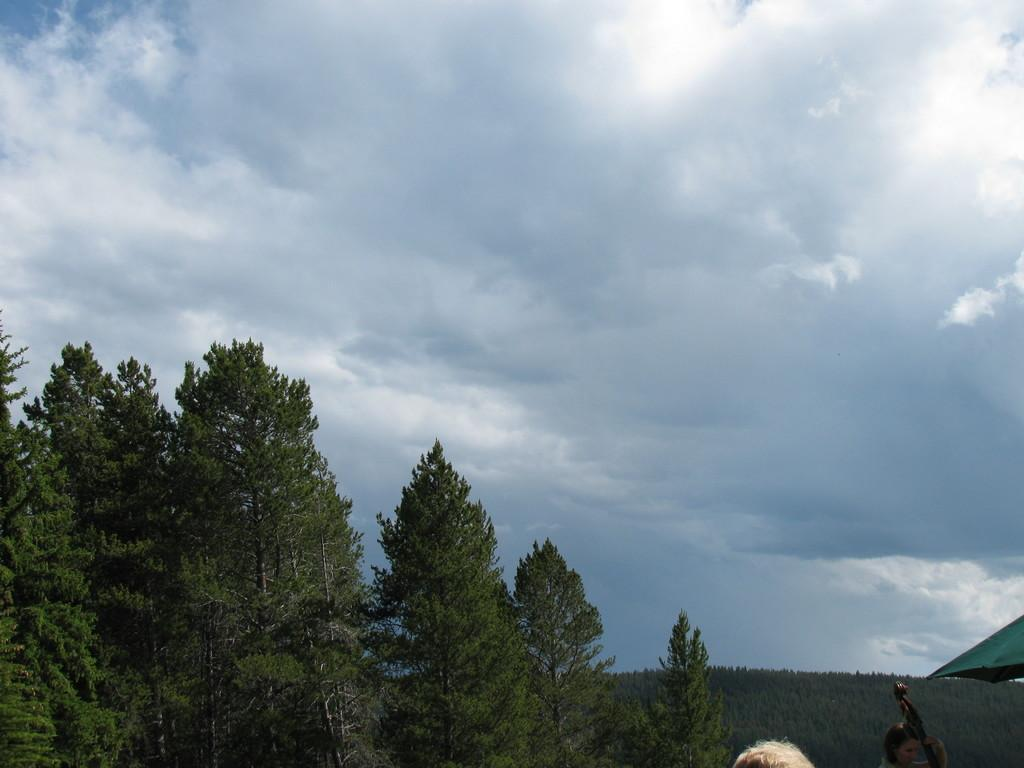What type of natural vegetation can be seen in the image? There are trees in the image. What object is present for protection from the elements? There is an umbrella in the image. What can be seen in the sky in the image? There are clouds visible in the image. Is there a person present in the image? Yes, there is a person in the image. What type of soup is being served in the image? There is no soup present in the image. What record is being played in the background of the image? There is no record or music player present in the image. 